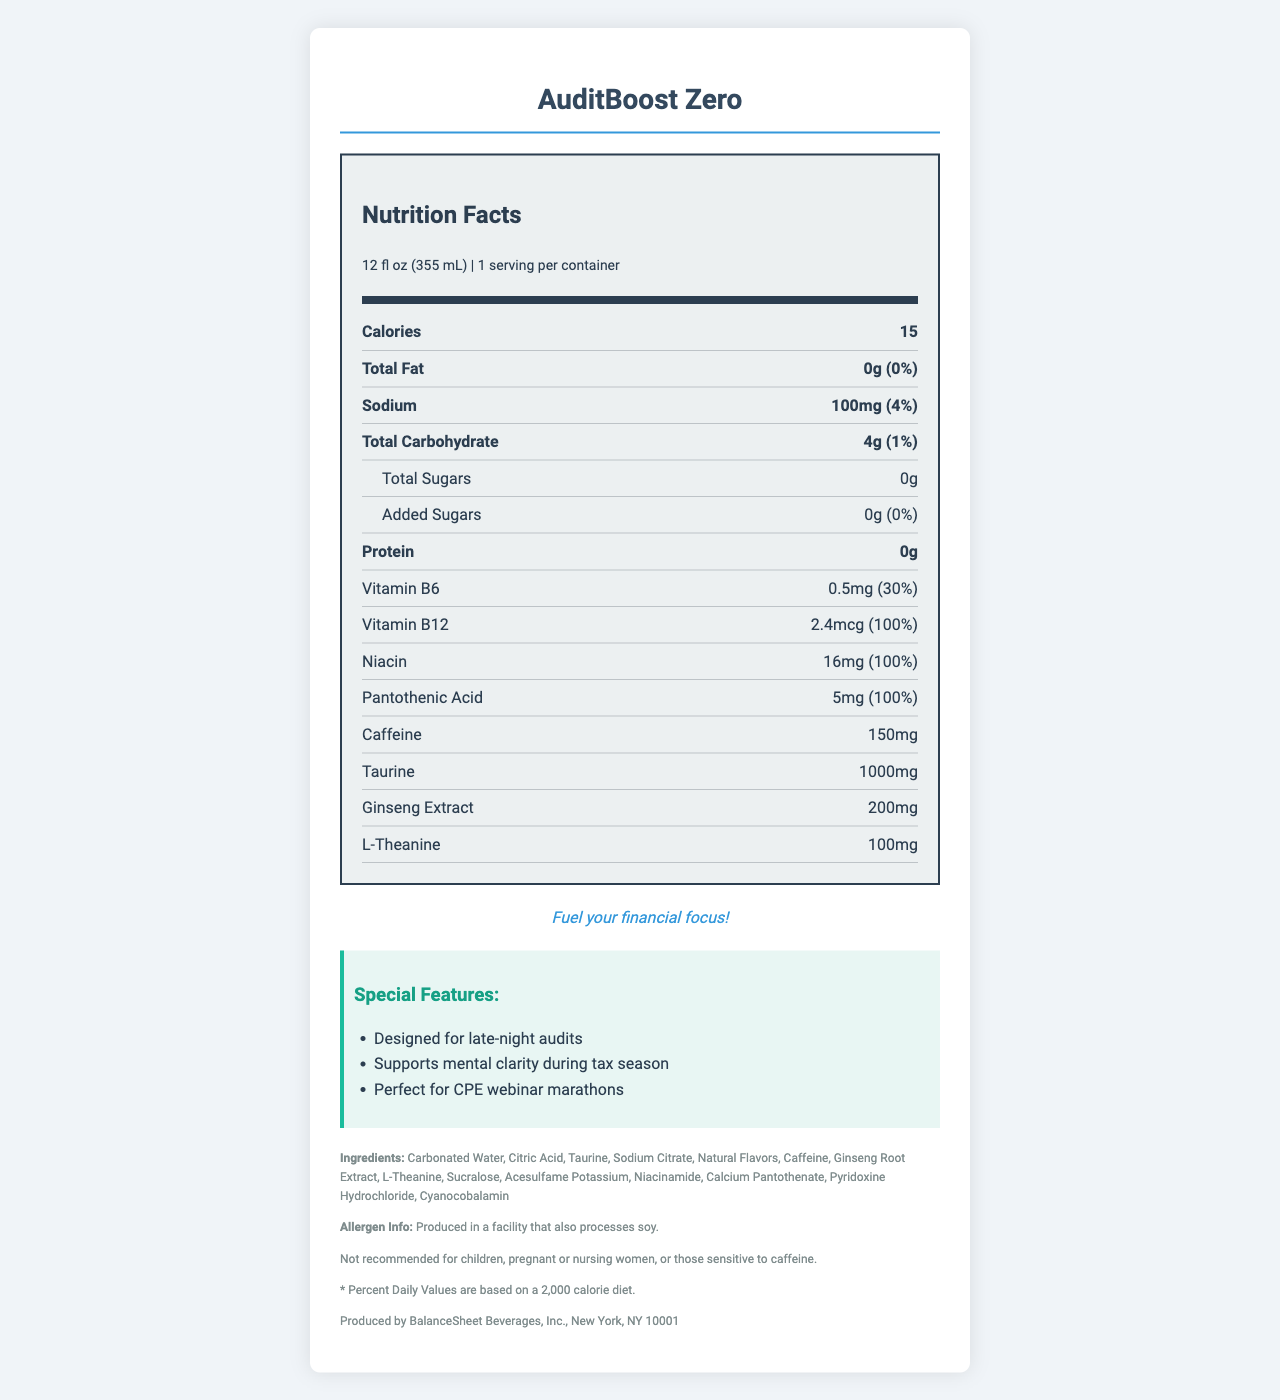what is the serving size for AuditBoost Zero? The serving size is indicated in the serving information section at the top of the nutrition label.
Answer: 12 fl oz (355 mL) how many calories does AuditBoost Zero contain per serving? The number of calories per serving is listed at the top of the nutrition label.
Answer: 15 how much sodium is in AuditBoost Zero? The amount of sodium is listed in the bold entry for Sodium along with its daily value percentage.
Answer: 100mg how much caffeine is in one serving of AuditBoost Zero? The amount of caffeine is specifically listed in the nutrition label section.
Answer: 150mg name three special features of AuditBoost Zero. These are listed under the Special Features section of the document.
Answer: Designed for late-night audits, Supports mental clarity during tax season, Perfect for CPE webinar marathons what percentage of the daily value of Vitamin B12 is included in AuditBoost Zero? The percentage for Vitamin B12's daily value is indicated in the detailed nutrition facts section.
Answer: 100% which ingredient listed is responsible for the sweetness without adding sugars? Both Sucralose and Acesulfame Potassium are artificial sweeteners listed in the ingredients section.
Answer: Sucralose, Acesulfame Potassium how much protein is in a serving of AuditBoost Zero? The amount of protein is listed in the bold entry for Protein.
Answer: 0g what is the tagline of AuditBoost Zero? The tagline is mentioned in italics below the nutrition facts section.
Answer: Fuel your financial focus! is the product suitable for children and pregnant women? The disclaimer explicitly states that it is not recommended for children, pregnant, or nursing women.
Answer: No how many grams of total sugars are there in AuditBoost Zero? The amount of total sugars is listed under the detailed nutrition facts section for Total Sugars.
Answer: 0g which of the following vitamins has the highest daily value percentage in AuditBoost Zero?
A. Vitamin B6
B. Vitamin B12
C. Niacin
D. Pantothenic Acid Vitamin B12 has a daily value percentage of 100%, the highest compared to the other listed vitamins.
Answer: B. Vitamin B12 how many servings are there per container of AuditBoost Zero?
I. 1
II. 2
III. 3
IV. 4 The number of servings per container is listed in the serving information section.
Answer: I. 1 does AuditBoost Zero contain added sugars? The nutrition label states that there are 0g of added sugars.
Answer: No summarize the main features and nutritional information of AuditBoost Zero. This provides a comprehensive overview, summarizing the key nutritional information, ingredients, and special features of the product.
Answer: AuditBoost Zero is a low-calorie energy drink designed for professionals, particularly beneficial during auditing and tax season. Each 12 fl oz serving contains 15 calories, 0g of fat, 100mg of sodium, 4g of carbohydrates, and 0g of protein. It includes significant amounts of Vitamin B6, Vitamin B12, Niacin, and Pantothenic Acid. The drink contains 150mg of caffeine, 1000mg of taurine, 200mg of ginseng extract, and 100mg of l-theanine. It is sweetened with sucralose and acesulfame potassium and is produced in a facility that processes soy. what is the price of AuditBoost Zero? The document does not contain any pricing information.
Answer: Not enough information 